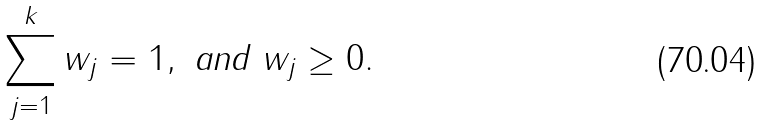Convert formula to latex. <formula><loc_0><loc_0><loc_500><loc_500>\sum _ { j = 1 } ^ { k } w _ { j } = 1 , \text { and } w _ { j } \geq 0 .</formula> 